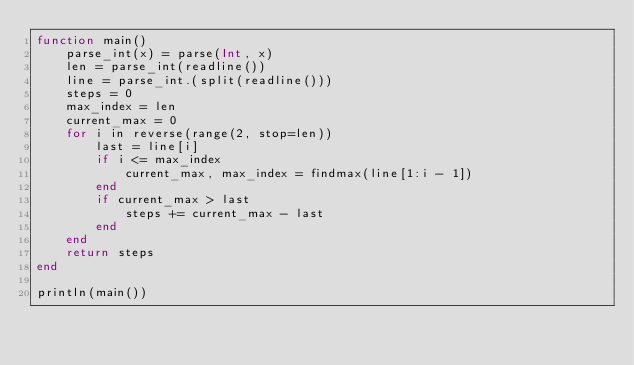<code> <loc_0><loc_0><loc_500><loc_500><_Julia_>function main()
    parse_int(x) = parse(Int, x)
    len = parse_int(readline())
    line = parse_int.(split(readline()))
    steps = 0
    max_index = len
    current_max = 0
    for i in reverse(range(2, stop=len))
        last = line[i]
        if i <= max_index
            current_max, max_index = findmax(line[1:i - 1]) 
        end
        if current_max > last
            steps += current_max - last 
        end
    end
    return steps
end

println(main())</code> 